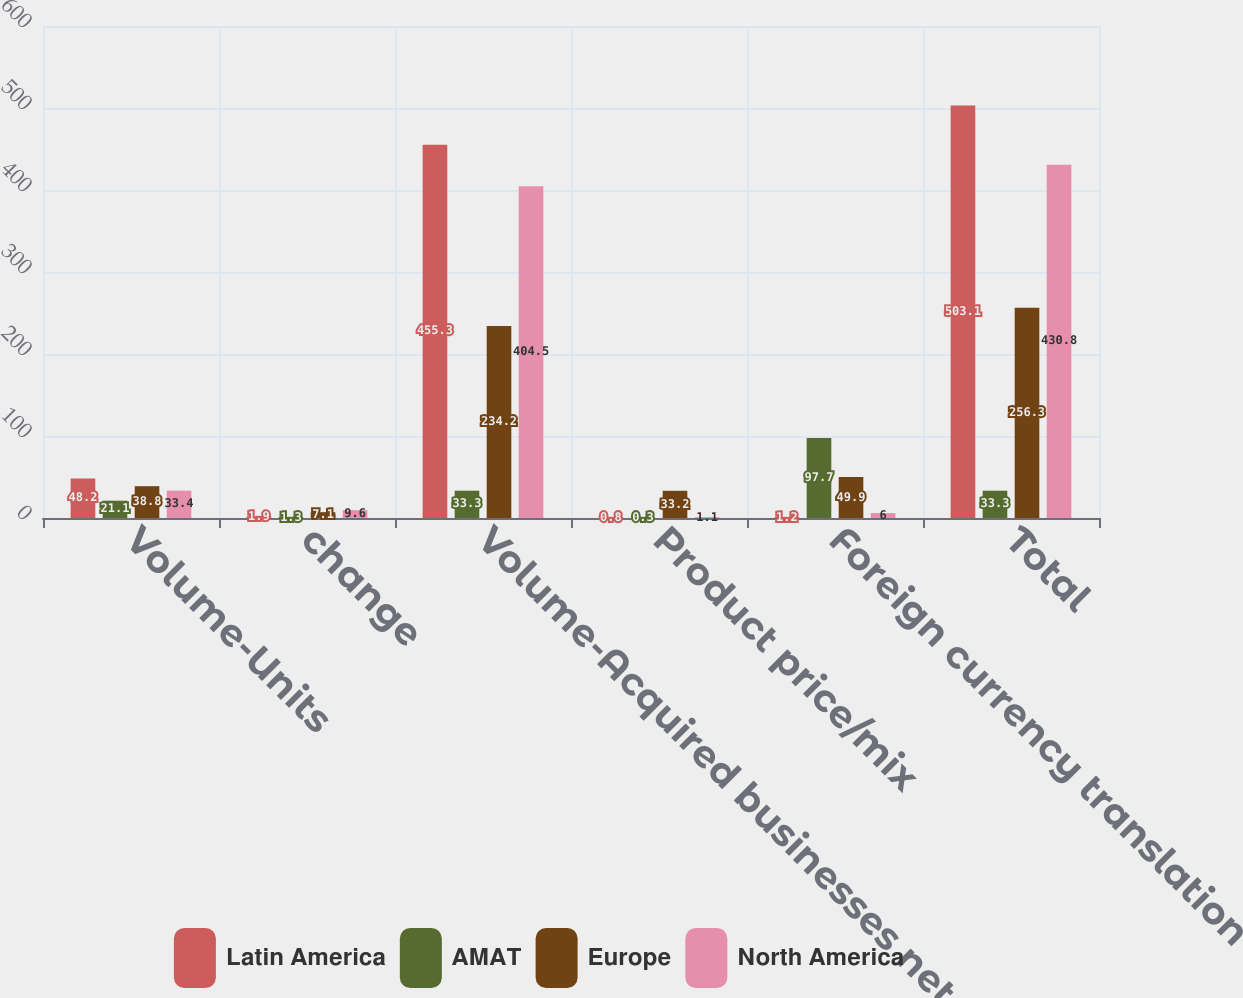Convert chart to OTSL. <chart><loc_0><loc_0><loc_500><loc_500><stacked_bar_chart><ecel><fcel>Volume-Units<fcel>change<fcel>Volume-Acquired businesses net<fcel>Product price/mix<fcel>Foreign currency translation<fcel>Total<nl><fcel>Latin America<fcel>48.2<fcel>1.9<fcel>455.3<fcel>0.8<fcel>1.2<fcel>503.1<nl><fcel>AMAT<fcel>21.1<fcel>1.3<fcel>33.3<fcel>0.3<fcel>97.7<fcel>33.3<nl><fcel>Europe<fcel>38.8<fcel>7.1<fcel>234.2<fcel>33.2<fcel>49.9<fcel>256.3<nl><fcel>North America<fcel>33.4<fcel>9.6<fcel>404.5<fcel>1.1<fcel>6<fcel>430.8<nl></chart> 